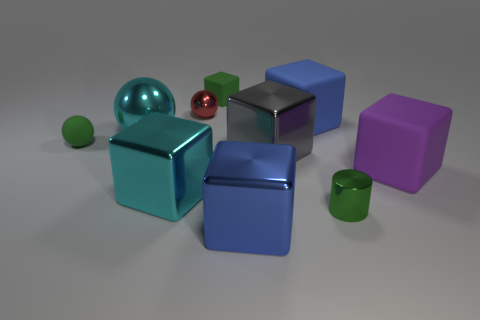Subtract all purple rubber cubes. How many cubes are left? 5 Subtract all gray cubes. How many cubes are left? 5 Subtract all cubes. How many objects are left? 4 Subtract 1 spheres. How many spheres are left? 2 Subtract all blue cylinders. Subtract all blue balls. How many cylinders are left? 1 Subtract all large spheres. Subtract all small red spheres. How many objects are left? 8 Add 3 small red metal spheres. How many small red metal spheres are left? 4 Add 9 tiny brown matte cubes. How many tiny brown matte cubes exist? 9 Subtract 0 yellow cubes. How many objects are left? 10 Subtract all blue balls. How many gray blocks are left? 1 